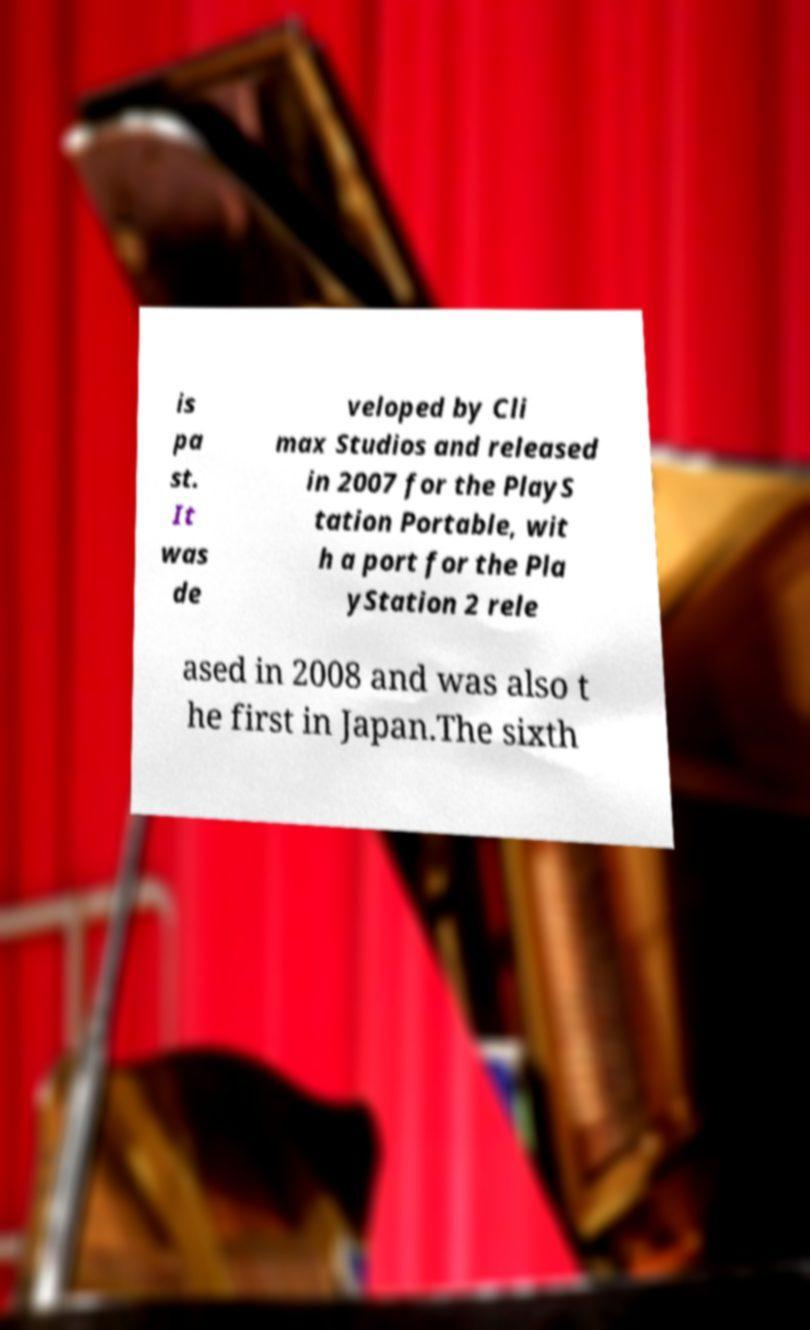Please identify and transcribe the text found in this image. is pa st. It was de veloped by Cli max Studios and released in 2007 for the PlayS tation Portable, wit h a port for the Pla yStation 2 rele ased in 2008 and was also t he first in Japan.The sixth 